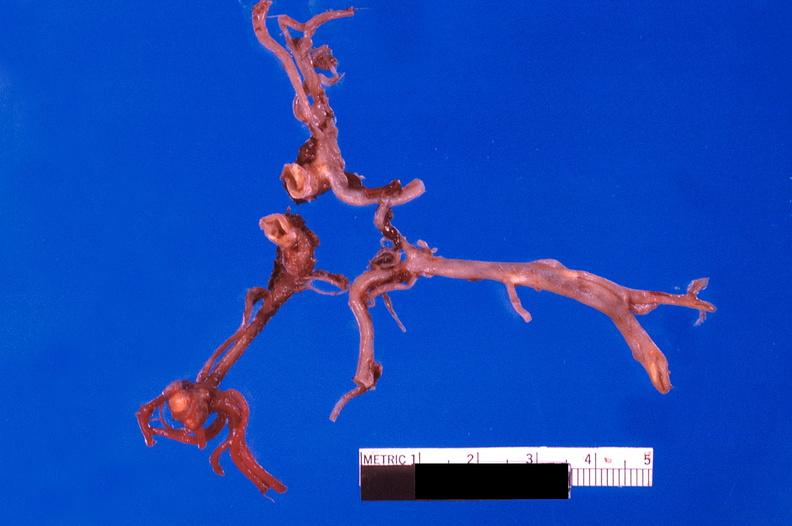what is present?
Answer the question using a single word or phrase. Vasculature 